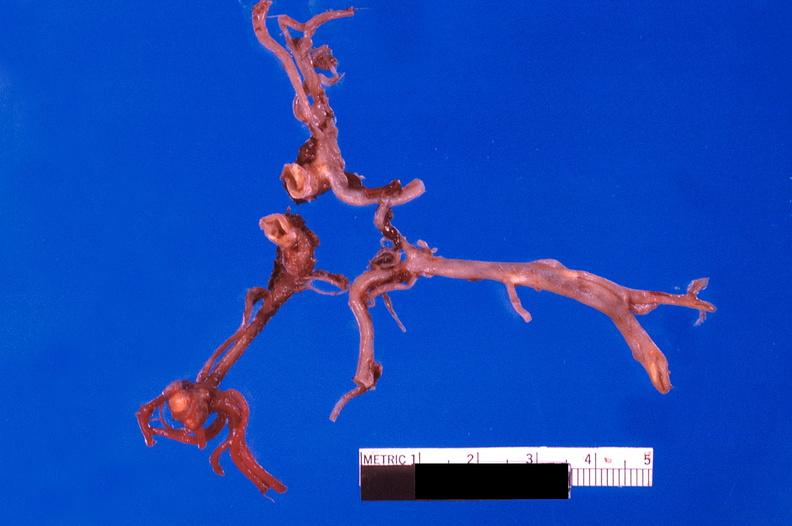what is present?
Answer the question using a single word or phrase. Vasculature 